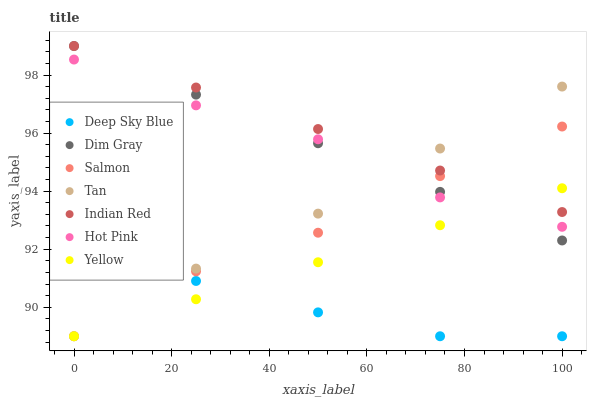Does Deep Sky Blue have the minimum area under the curve?
Answer yes or no. Yes. Does Indian Red have the maximum area under the curve?
Answer yes or no. Yes. Does Hot Pink have the minimum area under the curve?
Answer yes or no. No. Does Hot Pink have the maximum area under the curve?
Answer yes or no. No. Is Dim Gray the smoothest?
Answer yes or no. Yes. Is Hot Pink the roughest?
Answer yes or no. Yes. Is Deep Sky Blue the smoothest?
Answer yes or no. No. Is Deep Sky Blue the roughest?
Answer yes or no. No. Does Deep Sky Blue have the lowest value?
Answer yes or no. Yes. Does Hot Pink have the lowest value?
Answer yes or no. No. Does Indian Red have the highest value?
Answer yes or no. Yes. Does Hot Pink have the highest value?
Answer yes or no. No. Is Deep Sky Blue less than Indian Red?
Answer yes or no. Yes. Is Dim Gray greater than Deep Sky Blue?
Answer yes or no. Yes. Does Yellow intersect Indian Red?
Answer yes or no. Yes. Is Yellow less than Indian Red?
Answer yes or no. No. Is Yellow greater than Indian Red?
Answer yes or no. No. Does Deep Sky Blue intersect Indian Red?
Answer yes or no. No. 